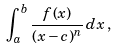Convert formula to latex. <formula><loc_0><loc_0><loc_500><loc_500>\int _ { a } ^ { b } \frac { f ( x ) } { ( x - c ) ^ { n } } \, d x \, ,</formula> 